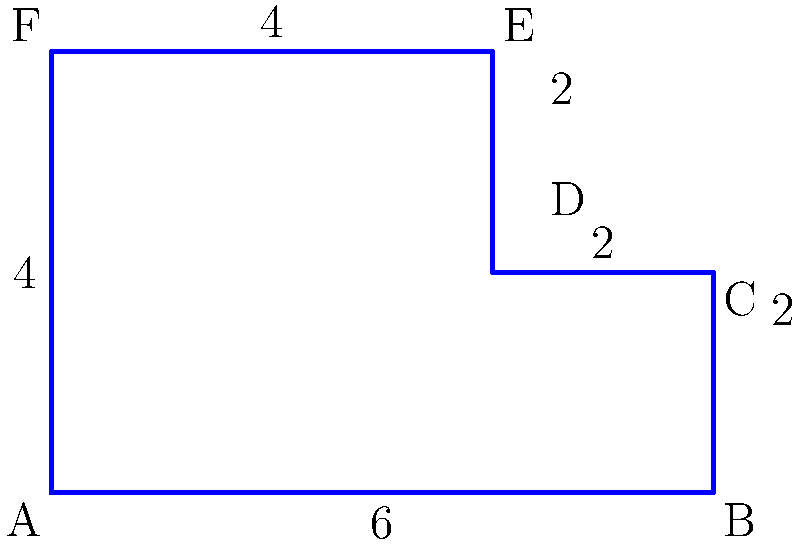As a product manager for an e-learning application, you're reviewing a new user interface layout. The layout is represented by the irregular polygon shown above. Calculate the perimeter of this layout to determine the total border length needed for the interface design. All measurements are in centimeters (cm). To calculate the perimeter of the irregular polygon, we need to sum up the lengths of all sides:

1. Side AB: $6$ cm
2. Side BC: $2$ cm
3. Side CD: $2$ cm
4. Side DE: $2$ cm
5. Side EF: $4$ cm
6. Side FA: $4$ cm

Sum up all the side lengths:

$$\text{Perimeter} = 6 + 2 + 2 + 2 + 4 + 4 = 20 \text{ cm}$$

Therefore, the total border length needed for the interface design is 20 cm.
Answer: $20$ cm 